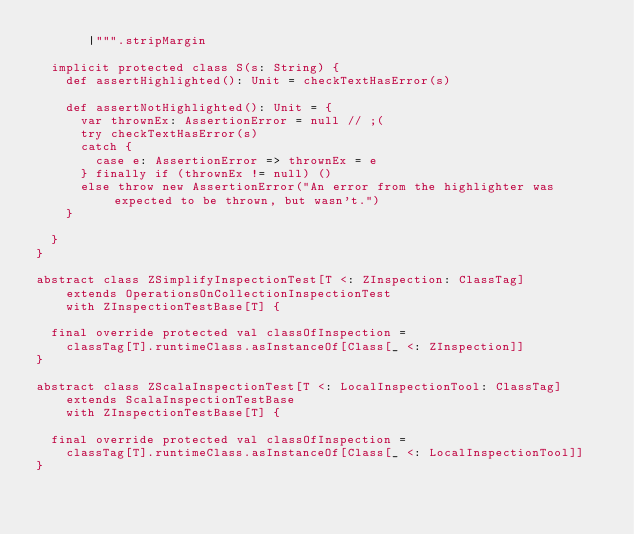<code> <loc_0><loc_0><loc_500><loc_500><_Scala_>       |""".stripMargin

  implicit protected class S(s: String) {
    def assertHighlighted(): Unit = checkTextHasError(s)

    def assertNotHighlighted(): Unit = {
      var thrownEx: AssertionError = null // ;(
      try checkTextHasError(s)
      catch {
        case e: AssertionError => thrownEx = e
      } finally if (thrownEx != null) ()
      else throw new AssertionError("An error from the highlighter was expected to be thrown, but wasn't.")
    }

  }
}

abstract class ZSimplifyInspectionTest[T <: ZInspection: ClassTag]
    extends OperationsOnCollectionInspectionTest
    with ZInspectionTestBase[T] {

  final override protected val classOfInspection =
    classTag[T].runtimeClass.asInstanceOf[Class[_ <: ZInspection]]
}

abstract class ZScalaInspectionTest[T <: LocalInspectionTool: ClassTag]
    extends ScalaInspectionTestBase
    with ZInspectionTestBase[T] {

  final override protected val classOfInspection =
    classTag[T].runtimeClass.asInstanceOf[Class[_ <: LocalInspectionTool]]
}
</code> 